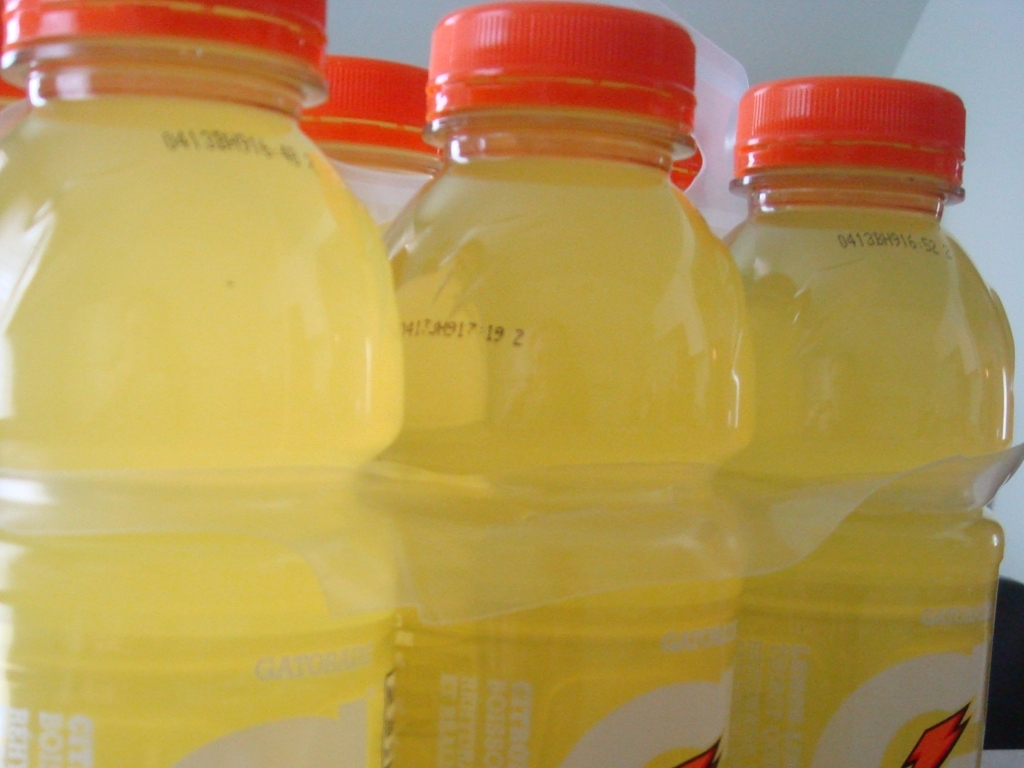Is this photo taken indoors or outdoors? The photo seems to be taken indoors owing to the even lighting and the lack of any discernible outdoor elements like sunlight, shadows, or natural landscapes. 